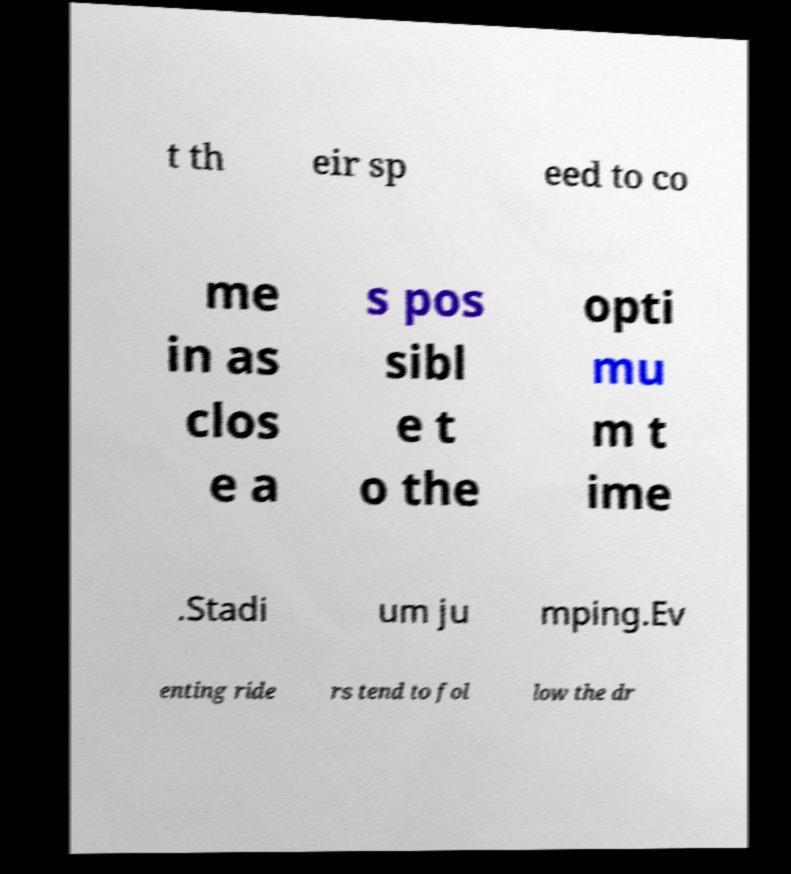For documentation purposes, I need the text within this image transcribed. Could you provide that? t th eir sp eed to co me in as clos e a s pos sibl e t o the opti mu m t ime .Stadi um ju mping.Ev enting ride rs tend to fol low the dr 